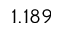<formula> <loc_0><loc_0><loc_500><loc_500>1 . 1 8 9</formula> 